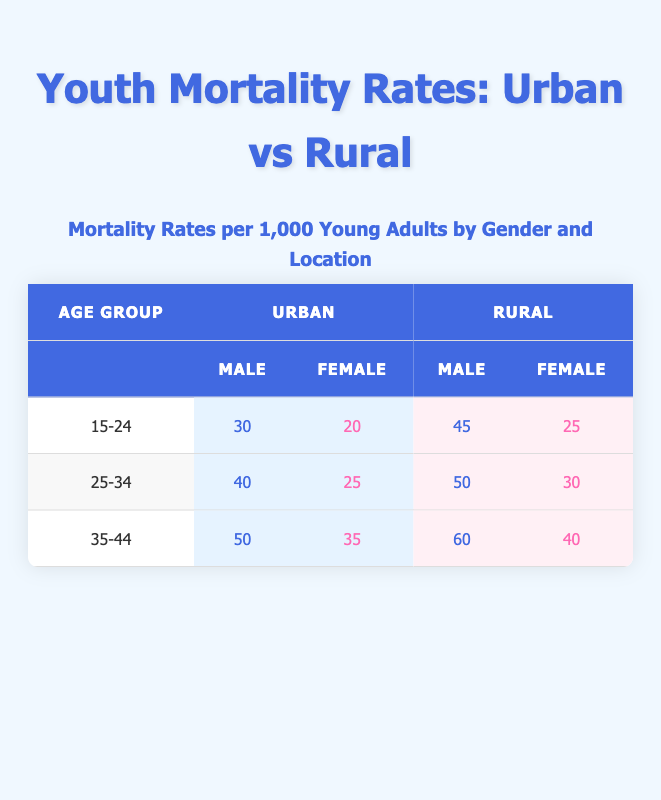What is the mortality rate for urban males aged 15-24? The table shows the mortality rate for urban males in the age group 15-24 is 30.
Answer: 30 Which gender has a higher mortality rate in rural areas for the age group 25-34? In the rural area for the age group 25-34, males have a mortality rate of 50 while females have a rate of 30. Therefore, males have a higher mortality rate.
Answer: Male What is the difference in mortality rates between urban female and rural female for the age group 35-44? The urban female rate for this age group is 35, while the rural rate is 40. The difference is calculated as 40 - 35 = 5.
Answer: 5 Is the mortality rate for urban female aged 25-34 lower than that for rural female of the same age group? The mortality rate for urban females aged 25-34 is 25, while the rural female rate is 30. Since 25 is less than 30, the statement is true.
Answer: Yes What are the average mortality rates of rural males across all age groups provided? The rural male rates are 45 (15-24), 50 (25-34), and 60 (35-44). The sum is 45 + 50 + 60 = 155, and the average is 155/3 = 51.67.
Answer: 51.67 What is the highest mortality rate recorded for females across both urban and rural settings? Reviewing the table, the highest mortality rate for females is in the rural area of the age group 35-44, which is 40.
Answer: 40 How many more urban males are expected to have a higher mortality rate than urban females in the age group 15-24? Urban males have a mortality rate of 30, while urban females have a rate of 20. The difference, and hence the number of males exceeding females in this age group, is 30 - 20 = 10.
Answer: 10 If we consider ages 15-34, which gender has a lower average mortality rate in urban areas? The urban male rates for ages 15-24 and 25-34 are 30 and 40 respectively, giving an average of (30 + 40)/2 = 35. The urban female rates are 20 and 25 respectively, giving an average of (20 + 25)/2 = 22.5. Since 22.5 is less than 35, females have the lower average mortality rate.
Answer: Female 